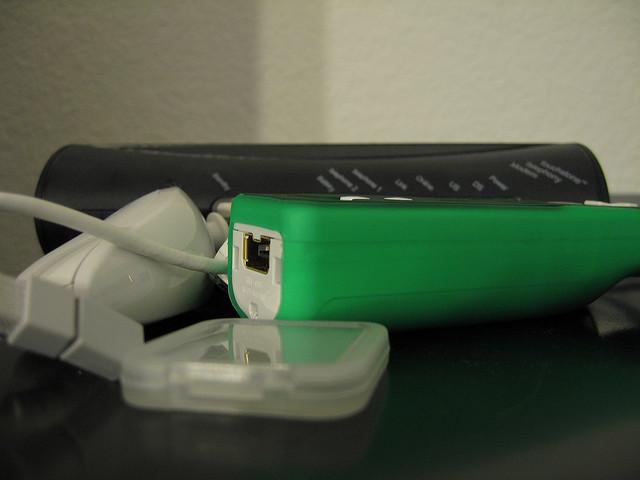Is the controller plugged in?
Quick response, please. No. Which handle is blue?
Answer briefly. None. What are the colors of the object?
Keep it brief. Green and white. What material are the controllers laying on?
Quick response, please. Plastic. Is this an airplane?
Concise answer only. No. Would any of these items need batteries?
Keep it brief. Yes. What color are the remotes?
Quick response, please. White. Will the remote work right now?
Keep it brief. Yes. Is a cell phone in the photo?
Quick response, please. No. 